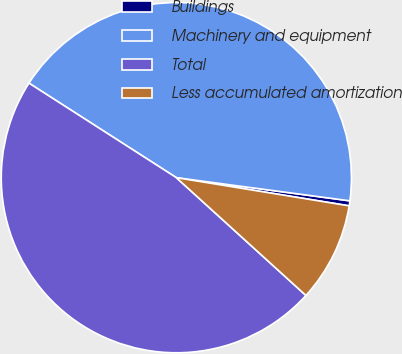Convert chart. <chart><loc_0><loc_0><loc_500><loc_500><pie_chart><fcel>Buildings<fcel>Machinery and equipment<fcel>Total<fcel>Less accumulated amortization<nl><fcel>0.46%<fcel>43.04%<fcel>47.34%<fcel>9.17%<nl></chart> 